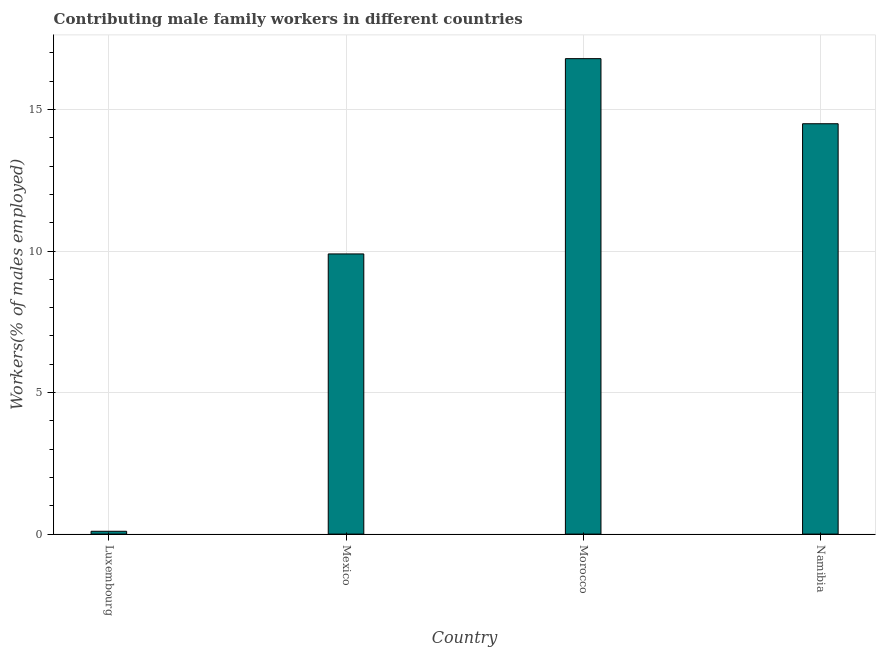What is the title of the graph?
Make the answer very short. Contributing male family workers in different countries. What is the label or title of the Y-axis?
Keep it short and to the point. Workers(% of males employed). What is the contributing male family workers in Luxembourg?
Provide a short and direct response. 0.1. Across all countries, what is the maximum contributing male family workers?
Give a very brief answer. 16.8. Across all countries, what is the minimum contributing male family workers?
Your answer should be compact. 0.1. In which country was the contributing male family workers maximum?
Offer a terse response. Morocco. In which country was the contributing male family workers minimum?
Provide a short and direct response. Luxembourg. What is the sum of the contributing male family workers?
Your answer should be compact. 41.3. What is the difference between the contributing male family workers in Luxembourg and Morocco?
Offer a terse response. -16.7. What is the average contributing male family workers per country?
Your response must be concise. 10.32. What is the median contributing male family workers?
Give a very brief answer. 12.2. In how many countries, is the contributing male family workers greater than 16 %?
Provide a succinct answer. 1. What is the ratio of the contributing male family workers in Luxembourg to that in Morocco?
Provide a succinct answer. 0.01. Is the contributing male family workers in Luxembourg less than that in Morocco?
Give a very brief answer. Yes. In how many countries, is the contributing male family workers greater than the average contributing male family workers taken over all countries?
Your answer should be compact. 2. Are all the bars in the graph horizontal?
Your response must be concise. No. What is the difference between two consecutive major ticks on the Y-axis?
Ensure brevity in your answer.  5. What is the Workers(% of males employed) in Luxembourg?
Your response must be concise. 0.1. What is the Workers(% of males employed) of Mexico?
Your response must be concise. 9.9. What is the Workers(% of males employed) in Morocco?
Your answer should be very brief. 16.8. What is the Workers(% of males employed) of Namibia?
Give a very brief answer. 14.5. What is the difference between the Workers(% of males employed) in Luxembourg and Morocco?
Your answer should be compact. -16.7. What is the difference between the Workers(% of males employed) in Luxembourg and Namibia?
Make the answer very short. -14.4. What is the difference between the Workers(% of males employed) in Mexico and Morocco?
Ensure brevity in your answer.  -6.9. What is the difference between the Workers(% of males employed) in Mexico and Namibia?
Give a very brief answer. -4.6. What is the ratio of the Workers(% of males employed) in Luxembourg to that in Morocco?
Make the answer very short. 0.01. What is the ratio of the Workers(% of males employed) in Luxembourg to that in Namibia?
Offer a terse response. 0.01. What is the ratio of the Workers(% of males employed) in Mexico to that in Morocco?
Offer a terse response. 0.59. What is the ratio of the Workers(% of males employed) in Mexico to that in Namibia?
Provide a short and direct response. 0.68. What is the ratio of the Workers(% of males employed) in Morocco to that in Namibia?
Give a very brief answer. 1.16. 